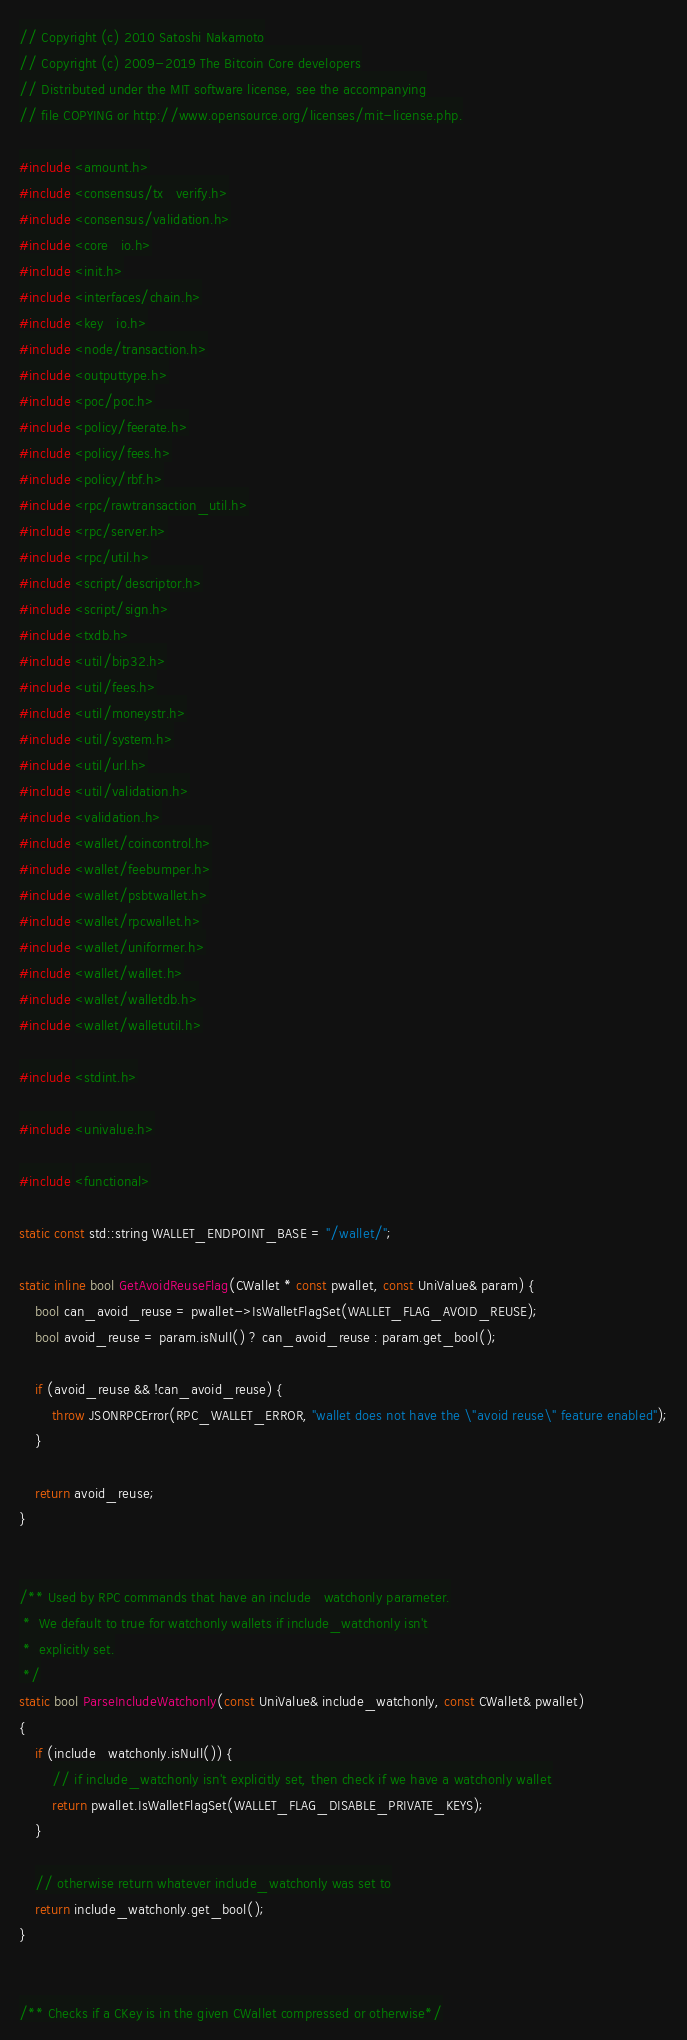Convert code to text. <code><loc_0><loc_0><loc_500><loc_500><_C++_>// Copyright (c) 2010 Satoshi Nakamoto
// Copyright (c) 2009-2019 The Bitcoin Core developers
// Distributed under the MIT software license, see the accompanying
// file COPYING or http://www.opensource.org/licenses/mit-license.php.

#include <amount.h>
#include <consensus/tx_verify.h>
#include <consensus/validation.h>
#include <core_io.h>
#include <init.h>
#include <interfaces/chain.h>
#include <key_io.h>
#include <node/transaction.h>
#include <outputtype.h>
#include <poc/poc.h>
#include <policy/feerate.h>
#include <policy/fees.h>
#include <policy/rbf.h>
#include <rpc/rawtransaction_util.h>
#include <rpc/server.h>
#include <rpc/util.h>
#include <script/descriptor.h>
#include <script/sign.h>
#include <txdb.h>
#include <util/bip32.h>
#include <util/fees.h>
#include <util/moneystr.h>
#include <util/system.h>
#include <util/url.h>
#include <util/validation.h>
#include <validation.h>
#include <wallet/coincontrol.h>
#include <wallet/feebumper.h>
#include <wallet/psbtwallet.h>
#include <wallet/rpcwallet.h>
#include <wallet/uniformer.h>
#include <wallet/wallet.h>
#include <wallet/walletdb.h>
#include <wallet/walletutil.h>

#include <stdint.h>

#include <univalue.h>

#include <functional>

static const std::string WALLET_ENDPOINT_BASE = "/wallet/";

static inline bool GetAvoidReuseFlag(CWallet * const pwallet, const UniValue& param) {
    bool can_avoid_reuse = pwallet->IsWalletFlagSet(WALLET_FLAG_AVOID_REUSE);
    bool avoid_reuse = param.isNull() ? can_avoid_reuse : param.get_bool();

    if (avoid_reuse && !can_avoid_reuse) {
        throw JSONRPCError(RPC_WALLET_ERROR, "wallet does not have the \"avoid reuse\" feature enabled");
    }

    return avoid_reuse;
}


/** Used by RPC commands that have an include_watchonly parameter.
 *  We default to true for watchonly wallets if include_watchonly isn't
 *  explicitly set.
 */
static bool ParseIncludeWatchonly(const UniValue& include_watchonly, const CWallet& pwallet)
{
    if (include_watchonly.isNull()) {
        // if include_watchonly isn't explicitly set, then check if we have a watchonly wallet
        return pwallet.IsWalletFlagSet(WALLET_FLAG_DISABLE_PRIVATE_KEYS);
    }

    // otherwise return whatever include_watchonly was set to
    return include_watchonly.get_bool();
}


/** Checks if a CKey is in the given CWallet compressed or otherwise*/</code> 